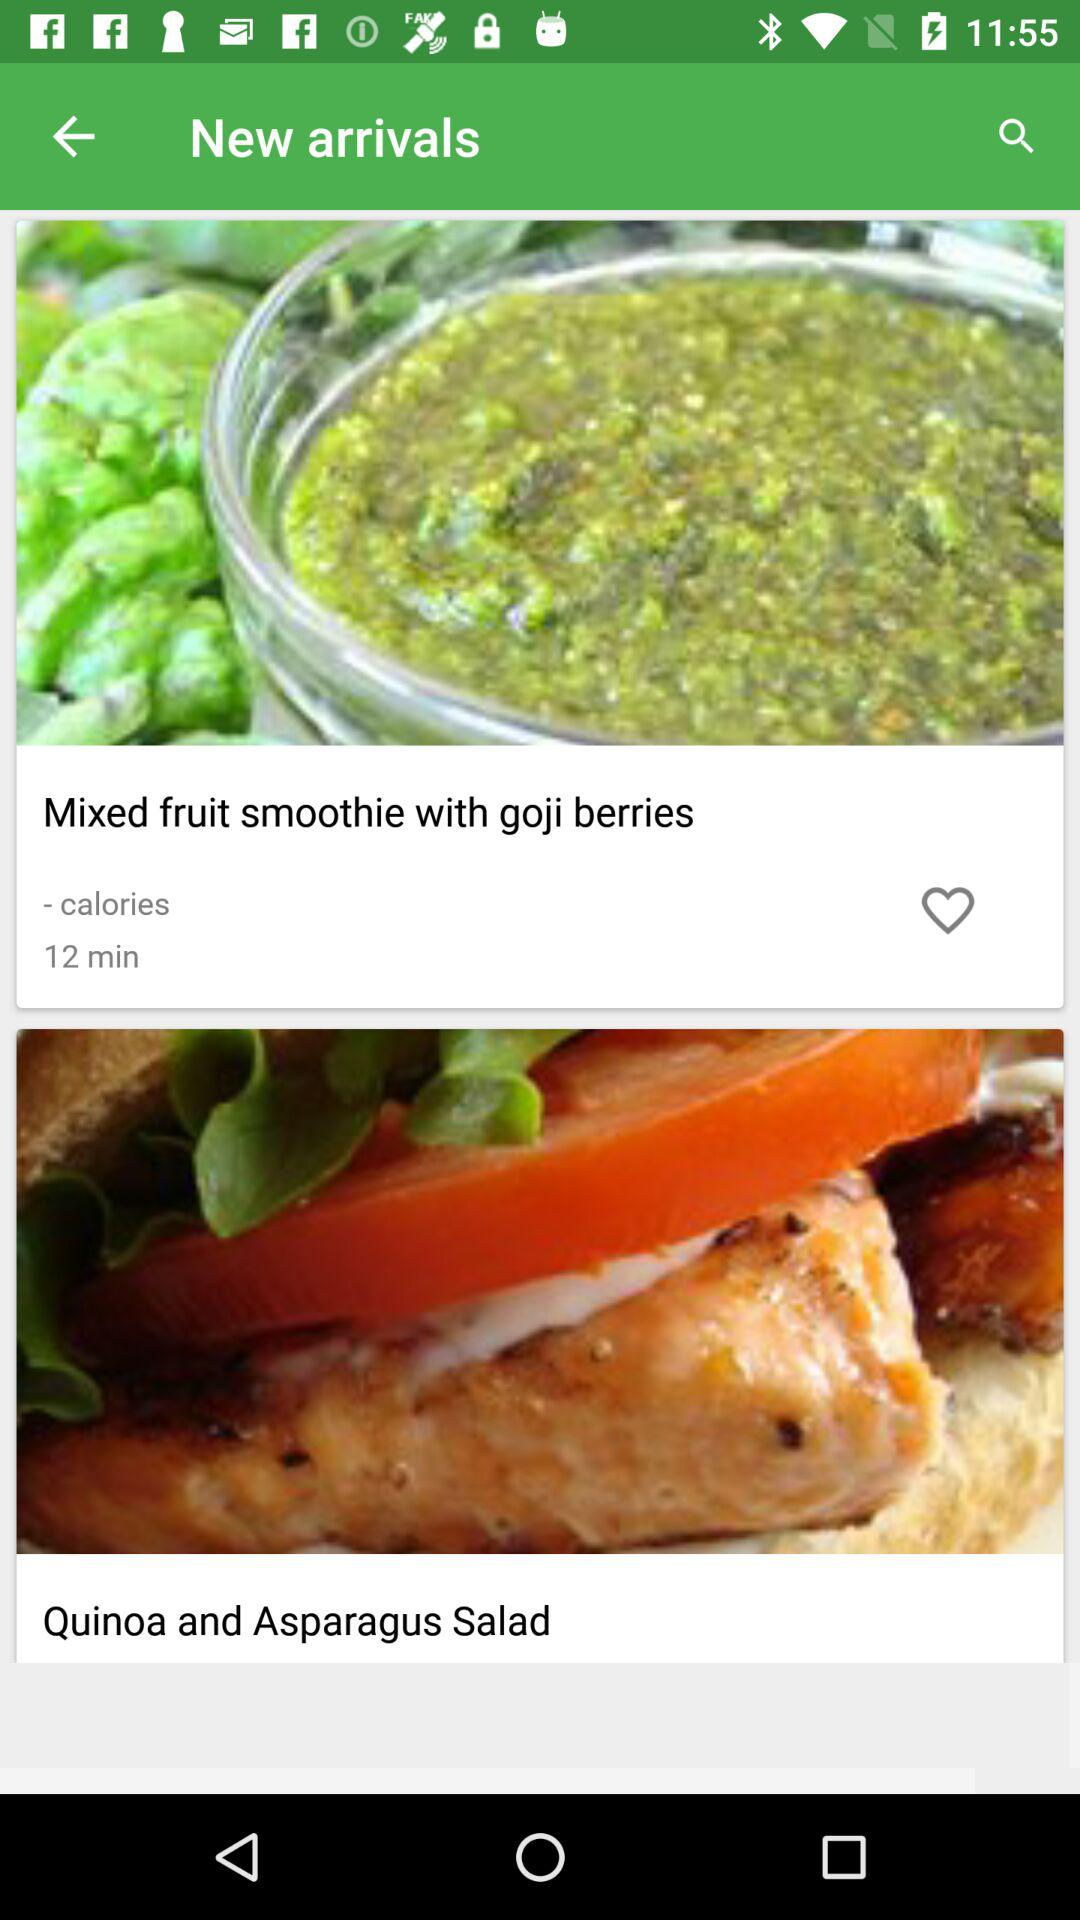What are the names of the recipes? The names of the recipes are "Mixed fruit smoothie with goji berries" and "Quinoa and Asparagus Salad". 